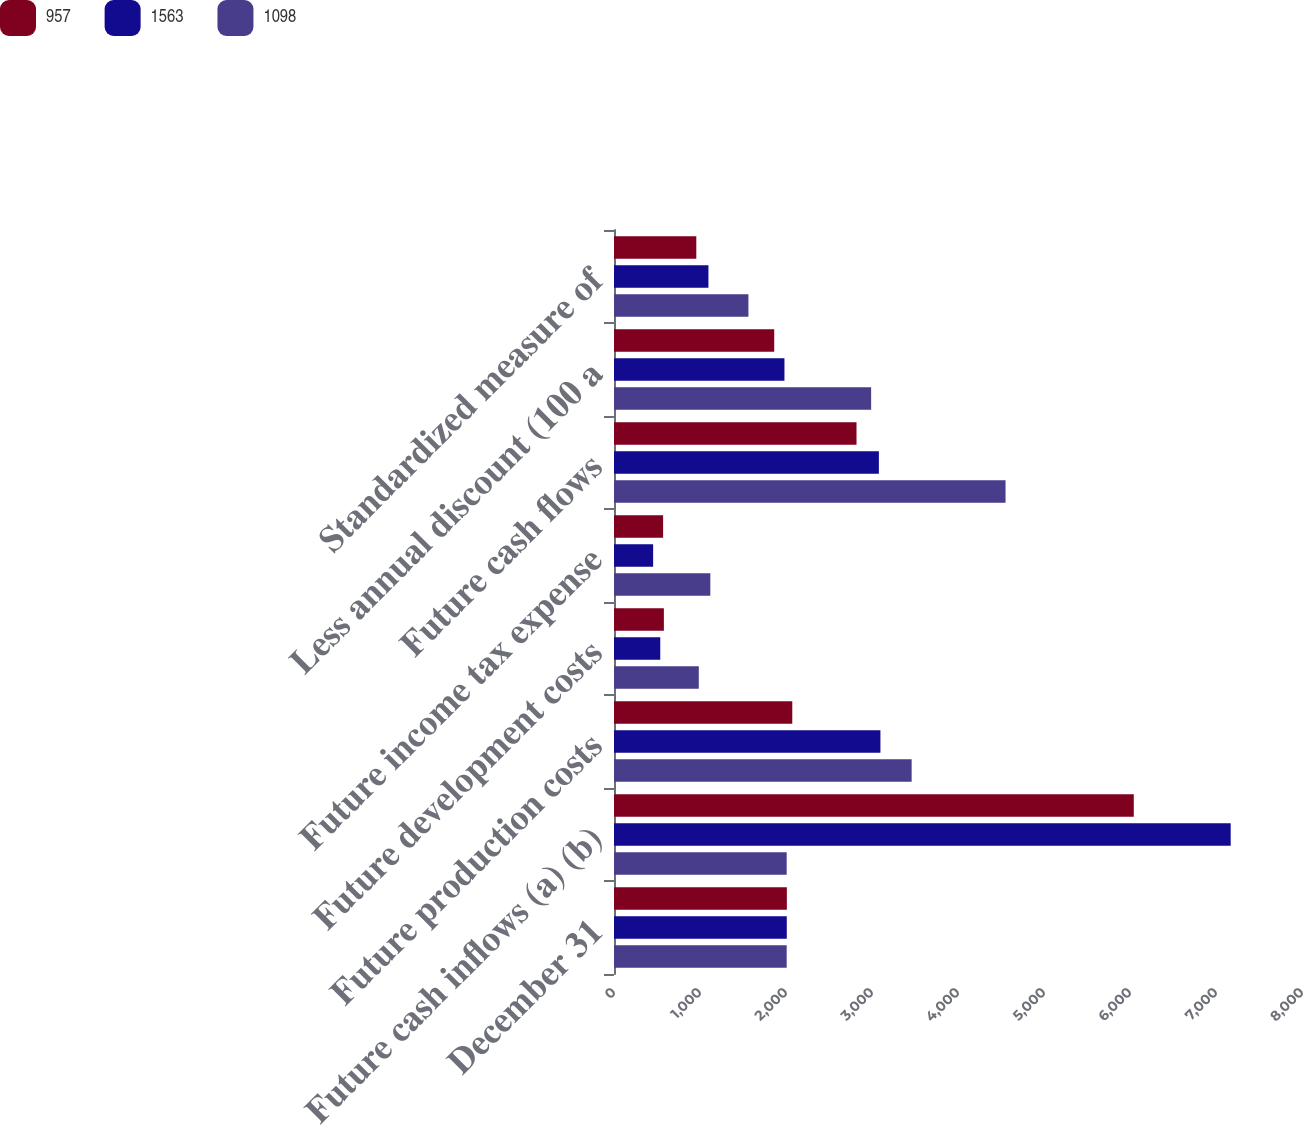Convert chart to OTSL. <chart><loc_0><loc_0><loc_500><loc_500><stacked_bar_chart><ecel><fcel>December 31<fcel>Future cash inflows (a) (b)<fcel>Future production costs<fcel>Future development costs<fcel>Future income tax expense<fcel>Future cash flows<fcel>Less annual discount (100 a<fcel>Standardized measure of<nl><fcel>957<fcel>2010<fcel>6044<fcel>2073<fcel>580<fcel>571<fcel>2820<fcel>1863<fcel>957<nl><fcel>1563<fcel>2009<fcel>7171<fcel>3098<fcel>538<fcel>455<fcel>3080<fcel>1982<fcel>1098<nl><fcel>1098<fcel>2008<fcel>2008<fcel>3461<fcel>986<fcel>1120<fcel>4553<fcel>2990<fcel>1563<nl></chart> 